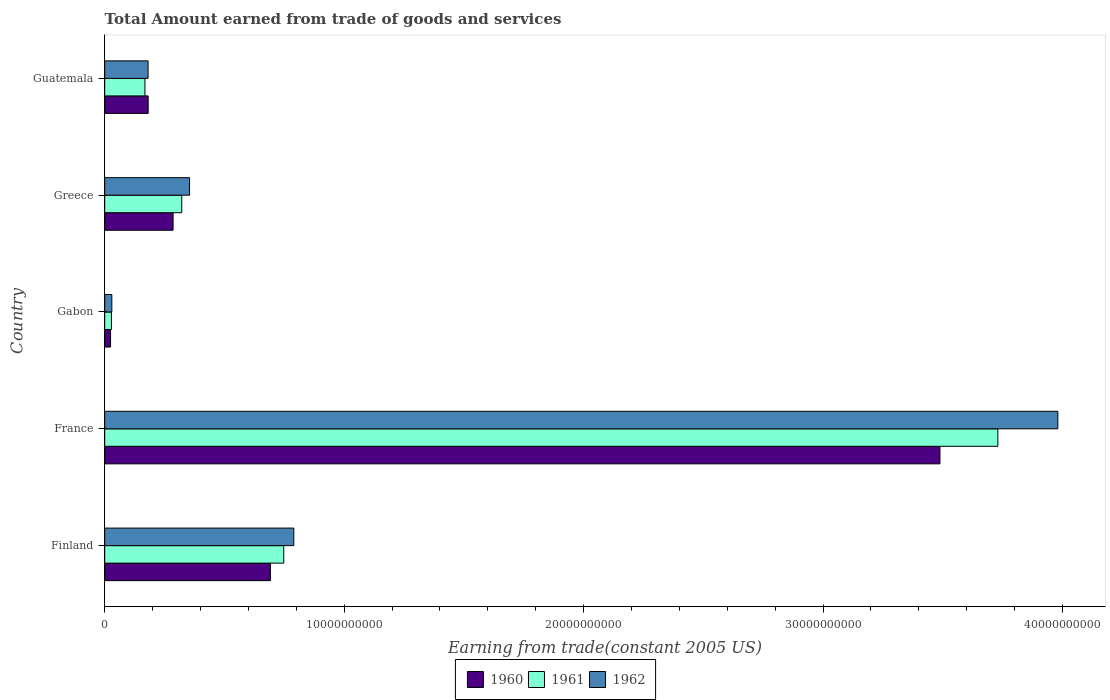How many groups of bars are there?
Provide a short and direct response. 5. Are the number of bars per tick equal to the number of legend labels?
Make the answer very short. Yes. Are the number of bars on each tick of the Y-axis equal?
Make the answer very short. Yes. What is the label of the 5th group of bars from the top?
Give a very brief answer. Finland. In how many cases, is the number of bars for a given country not equal to the number of legend labels?
Your answer should be very brief. 0. What is the total amount earned by trading goods and services in 1962 in Guatemala?
Your answer should be very brief. 1.81e+09. Across all countries, what is the maximum total amount earned by trading goods and services in 1962?
Give a very brief answer. 3.98e+1. Across all countries, what is the minimum total amount earned by trading goods and services in 1960?
Give a very brief answer. 2.44e+08. In which country was the total amount earned by trading goods and services in 1960 maximum?
Your answer should be compact. France. In which country was the total amount earned by trading goods and services in 1961 minimum?
Ensure brevity in your answer.  Gabon. What is the total total amount earned by trading goods and services in 1960 in the graph?
Your answer should be very brief. 4.67e+1. What is the difference between the total amount earned by trading goods and services in 1962 in France and that in Guatemala?
Provide a succinct answer. 3.80e+1. What is the difference between the total amount earned by trading goods and services in 1961 in Greece and the total amount earned by trading goods and services in 1960 in Guatemala?
Make the answer very short. 1.40e+09. What is the average total amount earned by trading goods and services in 1960 per country?
Ensure brevity in your answer.  9.34e+09. What is the difference between the total amount earned by trading goods and services in 1962 and total amount earned by trading goods and services in 1961 in Finland?
Your answer should be very brief. 4.20e+08. What is the ratio of the total amount earned by trading goods and services in 1962 in Finland to that in France?
Your response must be concise. 0.2. Is the total amount earned by trading goods and services in 1962 in Finland less than that in France?
Provide a short and direct response. Yes. What is the difference between the highest and the second highest total amount earned by trading goods and services in 1960?
Provide a short and direct response. 2.80e+1. What is the difference between the highest and the lowest total amount earned by trading goods and services in 1960?
Make the answer very short. 3.46e+1. In how many countries, is the total amount earned by trading goods and services in 1960 greater than the average total amount earned by trading goods and services in 1960 taken over all countries?
Provide a short and direct response. 1. How many countries are there in the graph?
Offer a terse response. 5. What is the difference between two consecutive major ticks on the X-axis?
Keep it short and to the point. 1.00e+1. How are the legend labels stacked?
Make the answer very short. Horizontal. What is the title of the graph?
Ensure brevity in your answer.  Total Amount earned from trade of goods and services. What is the label or title of the X-axis?
Give a very brief answer. Earning from trade(constant 2005 US). What is the label or title of the Y-axis?
Offer a very short reply. Country. What is the Earning from trade(constant 2005 US) of 1960 in Finland?
Provide a succinct answer. 6.92e+09. What is the Earning from trade(constant 2005 US) in 1961 in Finland?
Offer a terse response. 7.48e+09. What is the Earning from trade(constant 2005 US) of 1962 in Finland?
Your answer should be very brief. 7.90e+09. What is the Earning from trade(constant 2005 US) of 1960 in France?
Your answer should be very brief. 3.49e+1. What is the Earning from trade(constant 2005 US) of 1961 in France?
Your answer should be compact. 3.73e+1. What is the Earning from trade(constant 2005 US) of 1962 in France?
Offer a very short reply. 3.98e+1. What is the Earning from trade(constant 2005 US) in 1960 in Gabon?
Your response must be concise. 2.44e+08. What is the Earning from trade(constant 2005 US) of 1961 in Gabon?
Offer a very short reply. 2.80e+08. What is the Earning from trade(constant 2005 US) in 1962 in Gabon?
Provide a succinct answer. 2.97e+08. What is the Earning from trade(constant 2005 US) of 1960 in Greece?
Offer a very short reply. 2.85e+09. What is the Earning from trade(constant 2005 US) of 1961 in Greece?
Ensure brevity in your answer.  3.22e+09. What is the Earning from trade(constant 2005 US) in 1962 in Greece?
Keep it short and to the point. 3.54e+09. What is the Earning from trade(constant 2005 US) of 1960 in Guatemala?
Your answer should be very brief. 1.82e+09. What is the Earning from trade(constant 2005 US) of 1961 in Guatemala?
Ensure brevity in your answer.  1.68e+09. What is the Earning from trade(constant 2005 US) of 1962 in Guatemala?
Give a very brief answer. 1.81e+09. Across all countries, what is the maximum Earning from trade(constant 2005 US) in 1960?
Give a very brief answer. 3.49e+1. Across all countries, what is the maximum Earning from trade(constant 2005 US) in 1961?
Provide a succinct answer. 3.73e+1. Across all countries, what is the maximum Earning from trade(constant 2005 US) of 1962?
Your answer should be compact. 3.98e+1. Across all countries, what is the minimum Earning from trade(constant 2005 US) in 1960?
Your answer should be very brief. 2.44e+08. Across all countries, what is the minimum Earning from trade(constant 2005 US) in 1961?
Make the answer very short. 2.80e+08. Across all countries, what is the minimum Earning from trade(constant 2005 US) in 1962?
Keep it short and to the point. 2.97e+08. What is the total Earning from trade(constant 2005 US) in 1960 in the graph?
Your response must be concise. 4.67e+1. What is the total Earning from trade(constant 2005 US) in 1961 in the graph?
Make the answer very short. 5.00e+1. What is the total Earning from trade(constant 2005 US) in 1962 in the graph?
Give a very brief answer. 5.34e+1. What is the difference between the Earning from trade(constant 2005 US) of 1960 in Finland and that in France?
Keep it short and to the point. -2.80e+1. What is the difference between the Earning from trade(constant 2005 US) in 1961 in Finland and that in France?
Your answer should be very brief. -2.98e+1. What is the difference between the Earning from trade(constant 2005 US) in 1962 in Finland and that in France?
Keep it short and to the point. -3.19e+1. What is the difference between the Earning from trade(constant 2005 US) of 1960 in Finland and that in Gabon?
Provide a short and direct response. 6.68e+09. What is the difference between the Earning from trade(constant 2005 US) in 1961 in Finland and that in Gabon?
Your answer should be compact. 7.20e+09. What is the difference between the Earning from trade(constant 2005 US) of 1962 in Finland and that in Gabon?
Provide a succinct answer. 7.60e+09. What is the difference between the Earning from trade(constant 2005 US) in 1960 in Finland and that in Greece?
Your answer should be very brief. 4.07e+09. What is the difference between the Earning from trade(constant 2005 US) of 1961 in Finland and that in Greece?
Offer a very short reply. 4.26e+09. What is the difference between the Earning from trade(constant 2005 US) in 1962 in Finland and that in Greece?
Your answer should be very brief. 4.35e+09. What is the difference between the Earning from trade(constant 2005 US) in 1960 in Finland and that in Guatemala?
Ensure brevity in your answer.  5.11e+09. What is the difference between the Earning from trade(constant 2005 US) of 1961 in Finland and that in Guatemala?
Offer a terse response. 5.80e+09. What is the difference between the Earning from trade(constant 2005 US) of 1962 in Finland and that in Guatemala?
Provide a short and direct response. 6.09e+09. What is the difference between the Earning from trade(constant 2005 US) in 1960 in France and that in Gabon?
Keep it short and to the point. 3.46e+1. What is the difference between the Earning from trade(constant 2005 US) of 1961 in France and that in Gabon?
Provide a succinct answer. 3.70e+1. What is the difference between the Earning from trade(constant 2005 US) in 1962 in France and that in Gabon?
Your response must be concise. 3.95e+1. What is the difference between the Earning from trade(constant 2005 US) of 1960 in France and that in Greece?
Provide a succinct answer. 3.20e+1. What is the difference between the Earning from trade(constant 2005 US) of 1961 in France and that in Greece?
Provide a succinct answer. 3.41e+1. What is the difference between the Earning from trade(constant 2005 US) in 1962 in France and that in Greece?
Offer a very short reply. 3.63e+1. What is the difference between the Earning from trade(constant 2005 US) in 1960 in France and that in Guatemala?
Keep it short and to the point. 3.31e+1. What is the difference between the Earning from trade(constant 2005 US) in 1961 in France and that in Guatemala?
Your answer should be compact. 3.56e+1. What is the difference between the Earning from trade(constant 2005 US) of 1962 in France and that in Guatemala?
Provide a succinct answer. 3.80e+1. What is the difference between the Earning from trade(constant 2005 US) of 1960 in Gabon and that in Greece?
Make the answer very short. -2.61e+09. What is the difference between the Earning from trade(constant 2005 US) in 1961 in Gabon and that in Greece?
Ensure brevity in your answer.  -2.94e+09. What is the difference between the Earning from trade(constant 2005 US) in 1962 in Gabon and that in Greece?
Ensure brevity in your answer.  -3.25e+09. What is the difference between the Earning from trade(constant 2005 US) in 1960 in Gabon and that in Guatemala?
Offer a terse response. -1.57e+09. What is the difference between the Earning from trade(constant 2005 US) of 1961 in Gabon and that in Guatemala?
Make the answer very short. -1.40e+09. What is the difference between the Earning from trade(constant 2005 US) of 1962 in Gabon and that in Guatemala?
Offer a terse response. -1.51e+09. What is the difference between the Earning from trade(constant 2005 US) of 1960 in Greece and that in Guatemala?
Offer a terse response. 1.04e+09. What is the difference between the Earning from trade(constant 2005 US) in 1961 in Greece and that in Guatemala?
Offer a terse response. 1.54e+09. What is the difference between the Earning from trade(constant 2005 US) of 1962 in Greece and that in Guatemala?
Your response must be concise. 1.73e+09. What is the difference between the Earning from trade(constant 2005 US) in 1960 in Finland and the Earning from trade(constant 2005 US) in 1961 in France?
Provide a short and direct response. -3.04e+1. What is the difference between the Earning from trade(constant 2005 US) in 1960 in Finland and the Earning from trade(constant 2005 US) in 1962 in France?
Provide a succinct answer. -3.29e+1. What is the difference between the Earning from trade(constant 2005 US) of 1961 in Finland and the Earning from trade(constant 2005 US) of 1962 in France?
Make the answer very short. -3.23e+1. What is the difference between the Earning from trade(constant 2005 US) in 1960 in Finland and the Earning from trade(constant 2005 US) in 1961 in Gabon?
Make the answer very short. 6.64e+09. What is the difference between the Earning from trade(constant 2005 US) in 1960 in Finland and the Earning from trade(constant 2005 US) in 1962 in Gabon?
Provide a short and direct response. 6.62e+09. What is the difference between the Earning from trade(constant 2005 US) in 1961 in Finland and the Earning from trade(constant 2005 US) in 1962 in Gabon?
Your answer should be compact. 7.18e+09. What is the difference between the Earning from trade(constant 2005 US) in 1960 in Finland and the Earning from trade(constant 2005 US) in 1961 in Greece?
Make the answer very short. 3.70e+09. What is the difference between the Earning from trade(constant 2005 US) in 1960 in Finland and the Earning from trade(constant 2005 US) in 1962 in Greece?
Offer a terse response. 3.38e+09. What is the difference between the Earning from trade(constant 2005 US) of 1961 in Finland and the Earning from trade(constant 2005 US) of 1962 in Greece?
Ensure brevity in your answer.  3.93e+09. What is the difference between the Earning from trade(constant 2005 US) of 1960 in Finland and the Earning from trade(constant 2005 US) of 1961 in Guatemala?
Your response must be concise. 5.24e+09. What is the difference between the Earning from trade(constant 2005 US) of 1960 in Finland and the Earning from trade(constant 2005 US) of 1962 in Guatemala?
Offer a very short reply. 5.11e+09. What is the difference between the Earning from trade(constant 2005 US) in 1961 in Finland and the Earning from trade(constant 2005 US) in 1962 in Guatemala?
Your answer should be very brief. 5.67e+09. What is the difference between the Earning from trade(constant 2005 US) in 1960 in France and the Earning from trade(constant 2005 US) in 1961 in Gabon?
Ensure brevity in your answer.  3.46e+1. What is the difference between the Earning from trade(constant 2005 US) of 1960 in France and the Earning from trade(constant 2005 US) of 1962 in Gabon?
Your response must be concise. 3.46e+1. What is the difference between the Earning from trade(constant 2005 US) in 1961 in France and the Earning from trade(constant 2005 US) in 1962 in Gabon?
Ensure brevity in your answer.  3.70e+1. What is the difference between the Earning from trade(constant 2005 US) of 1960 in France and the Earning from trade(constant 2005 US) of 1961 in Greece?
Ensure brevity in your answer.  3.17e+1. What is the difference between the Earning from trade(constant 2005 US) of 1960 in France and the Earning from trade(constant 2005 US) of 1962 in Greece?
Keep it short and to the point. 3.13e+1. What is the difference between the Earning from trade(constant 2005 US) in 1961 in France and the Earning from trade(constant 2005 US) in 1962 in Greece?
Offer a terse response. 3.38e+1. What is the difference between the Earning from trade(constant 2005 US) in 1960 in France and the Earning from trade(constant 2005 US) in 1961 in Guatemala?
Make the answer very short. 3.32e+1. What is the difference between the Earning from trade(constant 2005 US) of 1960 in France and the Earning from trade(constant 2005 US) of 1962 in Guatemala?
Your answer should be very brief. 3.31e+1. What is the difference between the Earning from trade(constant 2005 US) in 1961 in France and the Earning from trade(constant 2005 US) in 1962 in Guatemala?
Ensure brevity in your answer.  3.55e+1. What is the difference between the Earning from trade(constant 2005 US) of 1960 in Gabon and the Earning from trade(constant 2005 US) of 1961 in Greece?
Your response must be concise. -2.97e+09. What is the difference between the Earning from trade(constant 2005 US) in 1960 in Gabon and the Earning from trade(constant 2005 US) in 1962 in Greece?
Offer a very short reply. -3.30e+09. What is the difference between the Earning from trade(constant 2005 US) in 1961 in Gabon and the Earning from trade(constant 2005 US) in 1962 in Greece?
Give a very brief answer. -3.26e+09. What is the difference between the Earning from trade(constant 2005 US) in 1960 in Gabon and the Earning from trade(constant 2005 US) in 1961 in Guatemala?
Your answer should be very brief. -1.44e+09. What is the difference between the Earning from trade(constant 2005 US) of 1960 in Gabon and the Earning from trade(constant 2005 US) of 1962 in Guatemala?
Offer a terse response. -1.57e+09. What is the difference between the Earning from trade(constant 2005 US) in 1961 in Gabon and the Earning from trade(constant 2005 US) in 1962 in Guatemala?
Your answer should be very brief. -1.53e+09. What is the difference between the Earning from trade(constant 2005 US) of 1960 in Greece and the Earning from trade(constant 2005 US) of 1961 in Guatemala?
Provide a succinct answer. 1.17e+09. What is the difference between the Earning from trade(constant 2005 US) in 1960 in Greece and the Earning from trade(constant 2005 US) in 1962 in Guatemala?
Your answer should be very brief. 1.04e+09. What is the difference between the Earning from trade(constant 2005 US) of 1961 in Greece and the Earning from trade(constant 2005 US) of 1962 in Guatemala?
Provide a short and direct response. 1.41e+09. What is the average Earning from trade(constant 2005 US) in 1960 per country?
Make the answer very short. 9.34e+09. What is the average Earning from trade(constant 2005 US) in 1961 per country?
Offer a terse response. 9.99e+09. What is the average Earning from trade(constant 2005 US) of 1962 per country?
Offer a terse response. 1.07e+1. What is the difference between the Earning from trade(constant 2005 US) of 1960 and Earning from trade(constant 2005 US) of 1961 in Finland?
Give a very brief answer. -5.58e+08. What is the difference between the Earning from trade(constant 2005 US) of 1960 and Earning from trade(constant 2005 US) of 1962 in Finland?
Provide a succinct answer. -9.78e+08. What is the difference between the Earning from trade(constant 2005 US) of 1961 and Earning from trade(constant 2005 US) of 1962 in Finland?
Ensure brevity in your answer.  -4.20e+08. What is the difference between the Earning from trade(constant 2005 US) of 1960 and Earning from trade(constant 2005 US) of 1961 in France?
Provide a short and direct response. -2.42e+09. What is the difference between the Earning from trade(constant 2005 US) in 1960 and Earning from trade(constant 2005 US) in 1962 in France?
Offer a very short reply. -4.92e+09. What is the difference between the Earning from trade(constant 2005 US) in 1961 and Earning from trade(constant 2005 US) in 1962 in France?
Your answer should be very brief. -2.50e+09. What is the difference between the Earning from trade(constant 2005 US) of 1960 and Earning from trade(constant 2005 US) of 1961 in Gabon?
Keep it short and to the point. -3.66e+07. What is the difference between the Earning from trade(constant 2005 US) of 1960 and Earning from trade(constant 2005 US) of 1962 in Gabon?
Your response must be concise. -5.31e+07. What is the difference between the Earning from trade(constant 2005 US) of 1961 and Earning from trade(constant 2005 US) of 1962 in Gabon?
Your answer should be very brief. -1.64e+07. What is the difference between the Earning from trade(constant 2005 US) in 1960 and Earning from trade(constant 2005 US) in 1961 in Greece?
Your answer should be compact. -3.63e+08. What is the difference between the Earning from trade(constant 2005 US) of 1960 and Earning from trade(constant 2005 US) of 1962 in Greece?
Your answer should be very brief. -6.88e+08. What is the difference between the Earning from trade(constant 2005 US) in 1961 and Earning from trade(constant 2005 US) in 1962 in Greece?
Ensure brevity in your answer.  -3.25e+08. What is the difference between the Earning from trade(constant 2005 US) of 1960 and Earning from trade(constant 2005 US) of 1961 in Guatemala?
Make the answer very short. 1.35e+08. What is the difference between the Earning from trade(constant 2005 US) of 1960 and Earning from trade(constant 2005 US) of 1962 in Guatemala?
Your response must be concise. 4.40e+06. What is the difference between the Earning from trade(constant 2005 US) in 1961 and Earning from trade(constant 2005 US) in 1962 in Guatemala?
Keep it short and to the point. -1.31e+08. What is the ratio of the Earning from trade(constant 2005 US) of 1960 in Finland to that in France?
Provide a succinct answer. 0.2. What is the ratio of the Earning from trade(constant 2005 US) of 1961 in Finland to that in France?
Offer a very short reply. 0.2. What is the ratio of the Earning from trade(constant 2005 US) in 1962 in Finland to that in France?
Provide a short and direct response. 0.2. What is the ratio of the Earning from trade(constant 2005 US) in 1960 in Finland to that in Gabon?
Provide a succinct answer. 28.38. What is the ratio of the Earning from trade(constant 2005 US) in 1961 in Finland to that in Gabon?
Ensure brevity in your answer.  26.67. What is the ratio of the Earning from trade(constant 2005 US) in 1962 in Finland to that in Gabon?
Your response must be concise. 26.6. What is the ratio of the Earning from trade(constant 2005 US) of 1960 in Finland to that in Greece?
Provide a short and direct response. 2.42. What is the ratio of the Earning from trade(constant 2005 US) in 1961 in Finland to that in Greece?
Your response must be concise. 2.32. What is the ratio of the Earning from trade(constant 2005 US) in 1962 in Finland to that in Greece?
Provide a short and direct response. 2.23. What is the ratio of the Earning from trade(constant 2005 US) of 1960 in Finland to that in Guatemala?
Your answer should be very brief. 3.81. What is the ratio of the Earning from trade(constant 2005 US) in 1961 in Finland to that in Guatemala?
Make the answer very short. 4.45. What is the ratio of the Earning from trade(constant 2005 US) in 1962 in Finland to that in Guatemala?
Make the answer very short. 4.36. What is the ratio of the Earning from trade(constant 2005 US) in 1960 in France to that in Gabon?
Your response must be concise. 143.08. What is the ratio of the Earning from trade(constant 2005 US) of 1961 in France to that in Gabon?
Provide a succinct answer. 133.02. What is the ratio of the Earning from trade(constant 2005 US) of 1962 in France to that in Gabon?
Keep it short and to the point. 134.1. What is the ratio of the Earning from trade(constant 2005 US) in 1960 in France to that in Greece?
Your answer should be very brief. 12.22. What is the ratio of the Earning from trade(constant 2005 US) in 1961 in France to that in Greece?
Your answer should be compact. 11.59. What is the ratio of the Earning from trade(constant 2005 US) in 1962 in France to that in Greece?
Your response must be concise. 11.24. What is the ratio of the Earning from trade(constant 2005 US) in 1960 in France to that in Guatemala?
Make the answer very short. 19.22. What is the ratio of the Earning from trade(constant 2005 US) of 1961 in France to that in Guatemala?
Keep it short and to the point. 22.2. What is the ratio of the Earning from trade(constant 2005 US) of 1962 in France to that in Guatemala?
Your response must be concise. 21.98. What is the ratio of the Earning from trade(constant 2005 US) of 1960 in Gabon to that in Greece?
Provide a succinct answer. 0.09. What is the ratio of the Earning from trade(constant 2005 US) of 1961 in Gabon to that in Greece?
Your response must be concise. 0.09. What is the ratio of the Earning from trade(constant 2005 US) in 1962 in Gabon to that in Greece?
Your answer should be compact. 0.08. What is the ratio of the Earning from trade(constant 2005 US) in 1960 in Gabon to that in Guatemala?
Offer a very short reply. 0.13. What is the ratio of the Earning from trade(constant 2005 US) in 1961 in Gabon to that in Guatemala?
Provide a short and direct response. 0.17. What is the ratio of the Earning from trade(constant 2005 US) in 1962 in Gabon to that in Guatemala?
Provide a short and direct response. 0.16. What is the ratio of the Earning from trade(constant 2005 US) in 1960 in Greece to that in Guatemala?
Give a very brief answer. 1.57. What is the ratio of the Earning from trade(constant 2005 US) of 1961 in Greece to that in Guatemala?
Offer a terse response. 1.92. What is the ratio of the Earning from trade(constant 2005 US) in 1962 in Greece to that in Guatemala?
Provide a short and direct response. 1.96. What is the difference between the highest and the second highest Earning from trade(constant 2005 US) in 1960?
Offer a very short reply. 2.80e+1. What is the difference between the highest and the second highest Earning from trade(constant 2005 US) of 1961?
Provide a succinct answer. 2.98e+1. What is the difference between the highest and the second highest Earning from trade(constant 2005 US) of 1962?
Keep it short and to the point. 3.19e+1. What is the difference between the highest and the lowest Earning from trade(constant 2005 US) of 1960?
Your answer should be very brief. 3.46e+1. What is the difference between the highest and the lowest Earning from trade(constant 2005 US) in 1961?
Give a very brief answer. 3.70e+1. What is the difference between the highest and the lowest Earning from trade(constant 2005 US) of 1962?
Provide a short and direct response. 3.95e+1. 